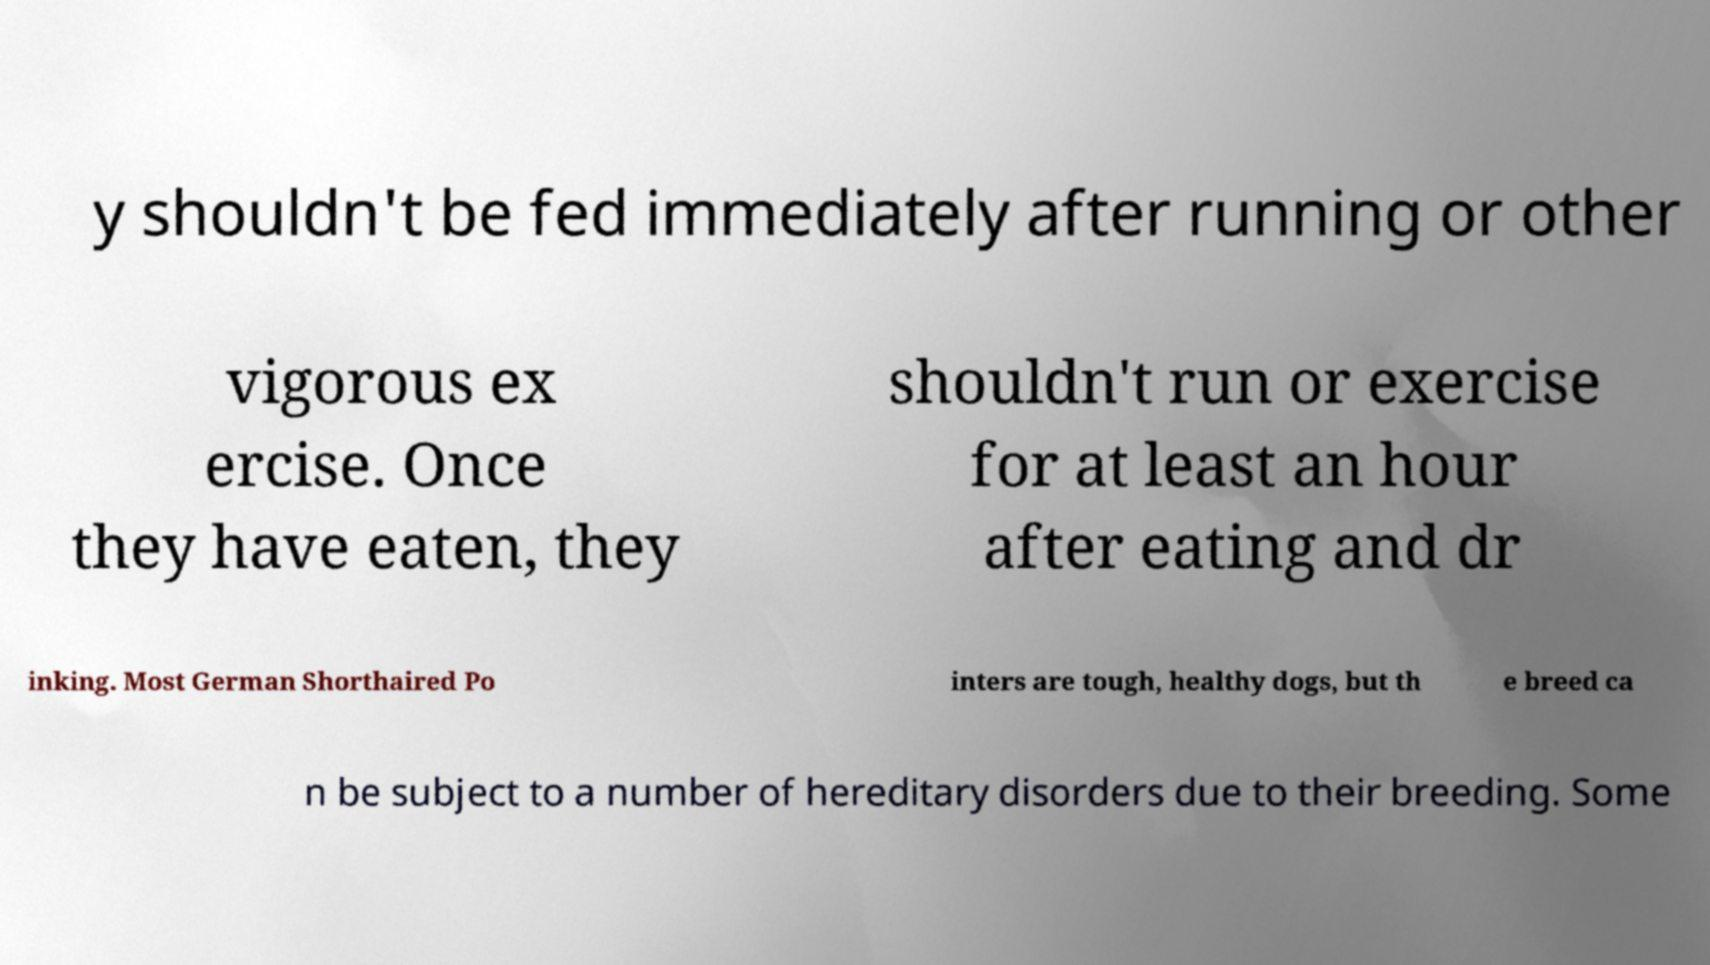I need the written content from this picture converted into text. Can you do that? y shouldn't be fed immediately after running or other vigorous ex ercise. Once they have eaten, they shouldn't run or exercise for at least an hour after eating and dr inking. Most German Shorthaired Po inters are tough, healthy dogs, but th e breed ca n be subject to a number of hereditary disorders due to their breeding. Some 